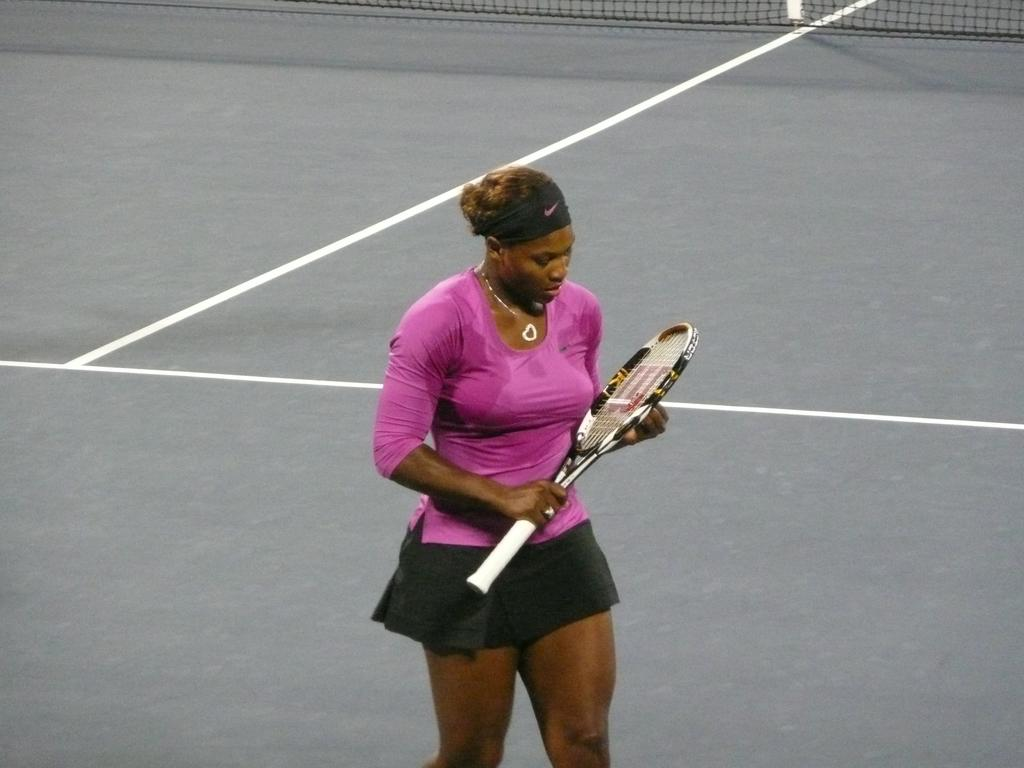Who is the main subject in the image? There is a woman in the image. Where is the woman positioned in the image? The woman is standing in the center of the image. What is the woman holding in her hand? The woman is holding a shuttle bat in her hand. What can be seen in the background of the image? There is a stadium in the background of the image. What is separating the two sides of the image? A net is visible in the image. What type of screw is being used to transport the woman in the image? There is no screw or transportation device present in the image; the woman is standing in the center of the image. What color is the cap on the woman's head in the image? There is no cap visible on the woman's head in the image. 